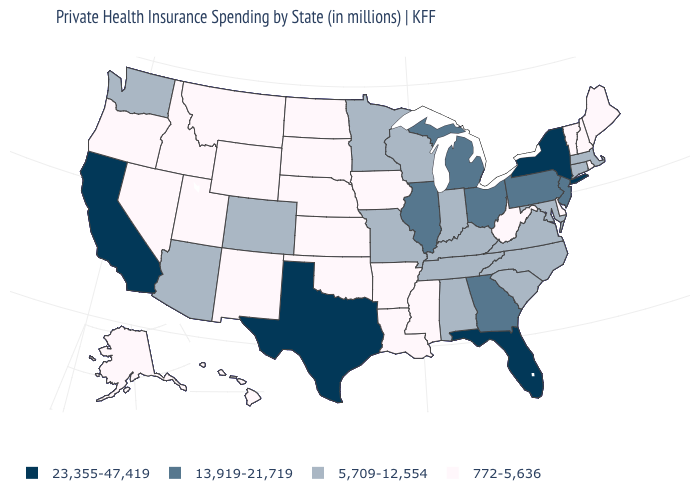What is the value of Colorado?
Keep it brief. 5,709-12,554. What is the value of Wyoming?
Keep it brief. 772-5,636. What is the value of Massachusetts?
Write a very short answer. 5,709-12,554. What is the value of North Dakota?
Short answer required. 772-5,636. Name the states that have a value in the range 23,355-47,419?
Give a very brief answer. California, Florida, New York, Texas. Name the states that have a value in the range 13,919-21,719?
Concise answer only. Georgia, Illinois, Michigan, New Jersey, Ohio, Pennsylvania. Does Iowa have a lower value than New Hampshire?
Be succinct. No. What is the lowest value in the USA?
Short answer required. 772-5,636. What is the value of Oklahoma?
Short answer required. 772-5,636. Name the states that have a value in the range 23,355-47,419?
Keep it brief. California, Florida, New York, Texas. What is the value of New Mexico?
Concise answer only. 772-5,636. Which states hav the highest value in the Northeast?
Short answer required. New York. Does Florida have the lowest value in the USA?
Give a very brief answer. No. What is the value of Iowa?
Give a very brief answer. 772-5,636. Among the states that border Virginia , does West Virginia have the lowest value?
Quick response, please. Yes. 